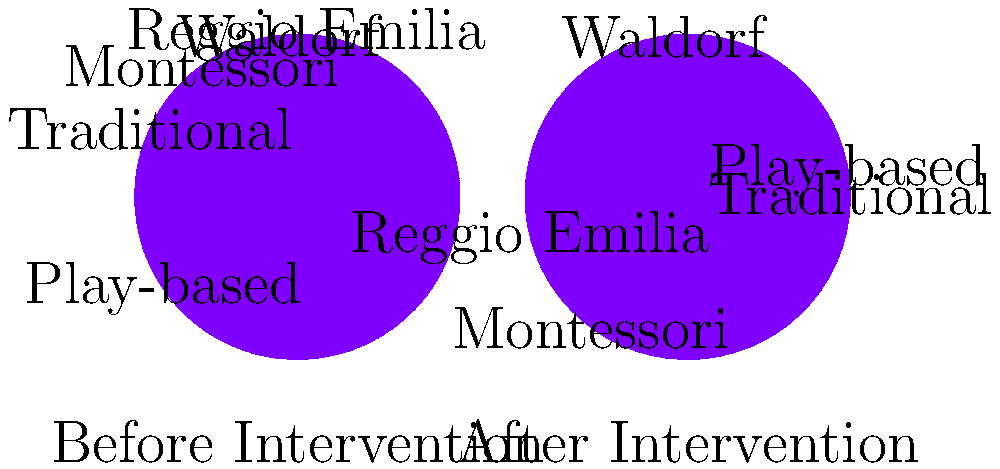The pie charts above represent the distribution of teaching methods used in early childhood education centers before and after an intervention program. Which teaching method showed the most significant increase in usage after the intervention, and what potential factors could have contributed to this change? To answer this question, we need to analyze the pie charts and compare the percentages for each teaching method before and after the intervention:

1. Play-based:
   Before: 30%, After: 35%
   Increase: 5%

2. Montessori:
   Before: 25%, After: 30%
   Increase: 5%

3. Reggio Emilia:
   Before: 20%, After: 15%
   Decrease: 5%

4. Waldorf:
   Before: 15%, After: 12%
   Decrease: 3%

5. Traditional:
   Before: 10%, After: 8%
   Decrease: 2%

The teaching method that showed the most significant increase in usage after the intervention was Play-based, with a 5% increase. Montessori also increased by 5%, but Play-based had a higher overall percentage.

Potential factors contributing to this change:

1. Research findings: Recent studies may have highlighted the benefits of play-based learning for early childhood development.

2. Teacher training: The intervention program might have included workshops or courses emphasizing play-based teaching strategies.

3. Parent preferences: Increased awareness among parents about the importance of play in learning could have influenced educational centers to adopt more play-based approaches.

4. Policy changes: New educational policies or guidelines might have encouraged the implementation of play-based learning in early childhood settings.

5. Resource allocation: The intervention could have provided resources (e.g., materials, equipment) that facilitate play-based learning environments.

6. Observed outcomes: Positive results in children's development and learning through play-based methods may have encouraged more centers to adopt this approach.

7. Alignment with developmental theories: The shift towards play-based learning aligns with current understanding of child development and how young children learn best.
Answer: Play-based learning; research findings, teacher training, parent preferences, policy changes, resource allocation, observed outcomes, and alignment with developmental theories. 